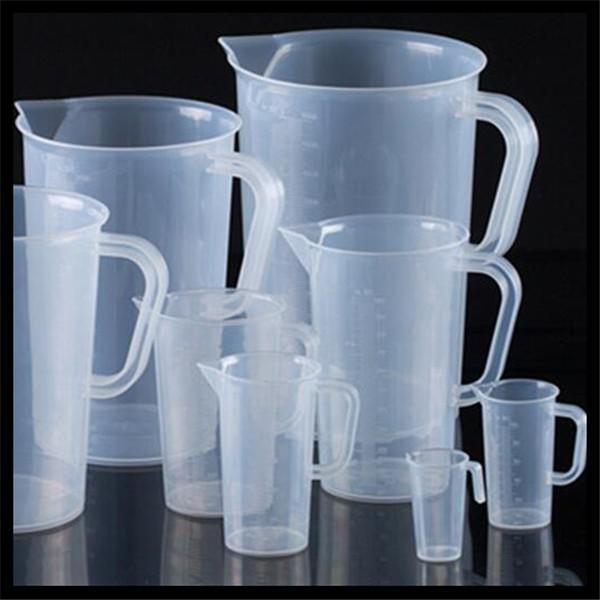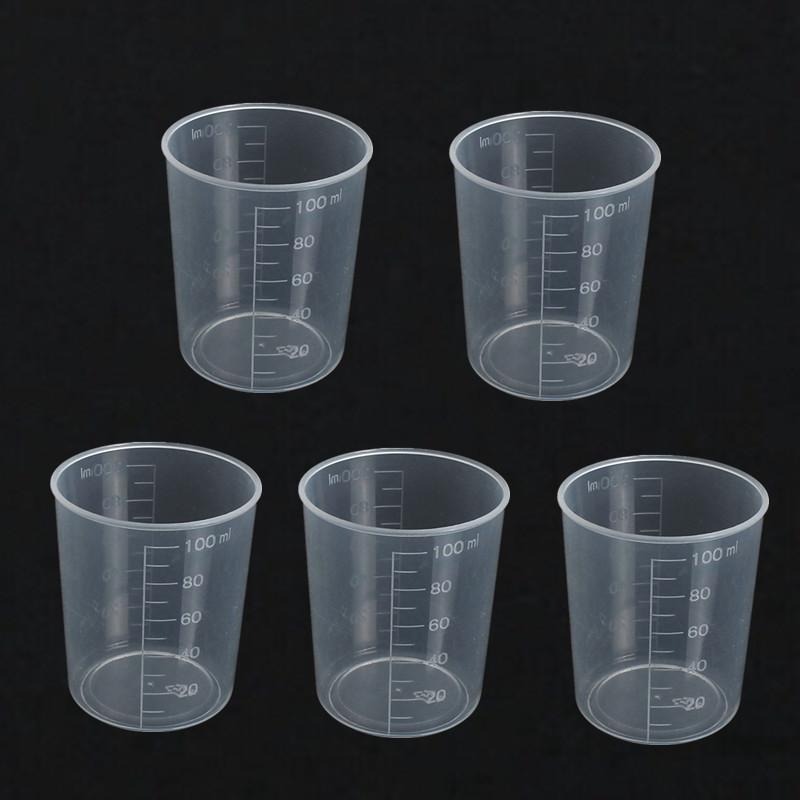The first image is the image on the left, the second image is the image on the right. Analyze the images presented: Is the assertion "One of the images contains exactly five measuring cups." valid? Answer yes or no. Yes. 